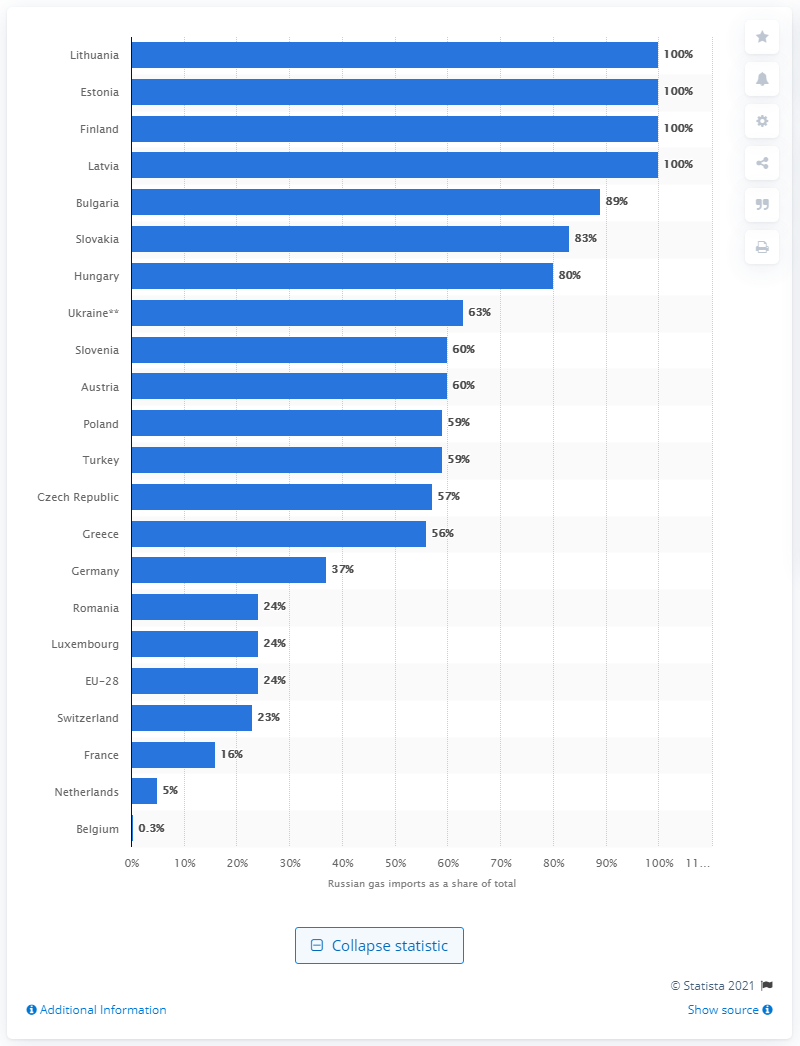List a handful of essential elements in this visual. According to data, approximately 59% of Bulgaria's total natural gas supply is based on. In 2012, Russia supplied 89% of Bulgaria's total natural gas demand. 